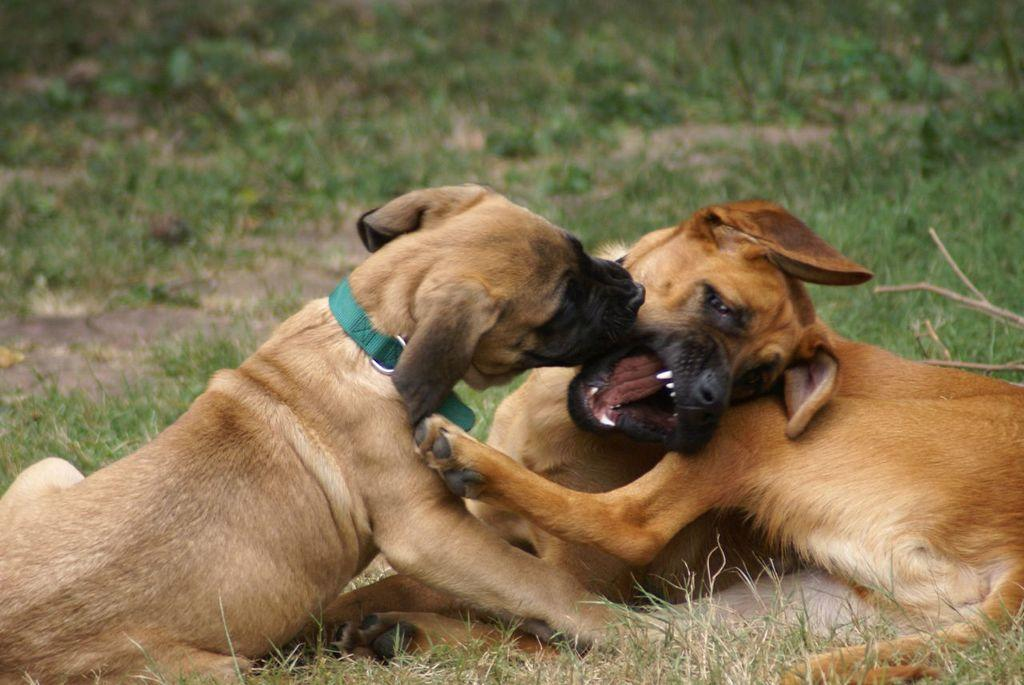How many dogs are present in the image? There are two dogs in the image. What is the dogs' location in the image? The dogs are sitting on grassy land. What is the reaction of the dogs' mom to the disgusting trucks in the image? There are no trucks or any indication of disgust in the image, and there is no mention of a mom. 